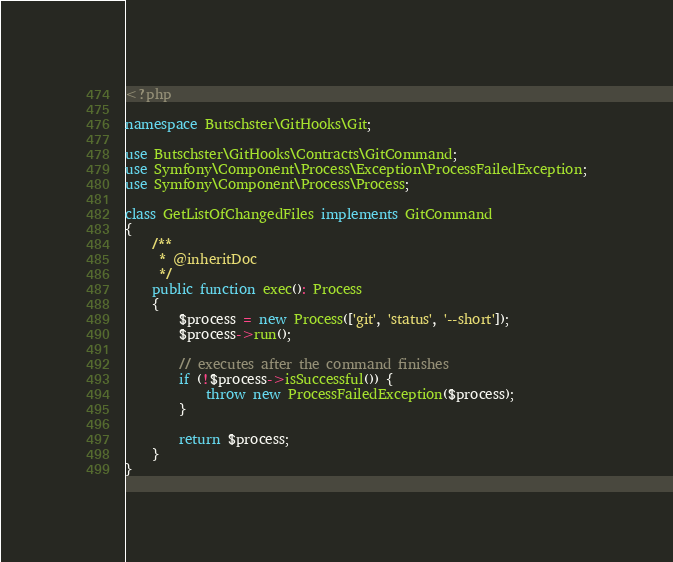<code> <loc_0><loc_0><loc_500><loc_500><_PHP_><?php

namespace Butschster\GitHooks\Git;

use Butschster\GitHooks\Contracts\GitCommand;
use Symfony\Component\Process\Exception\ProcessFailedException;
use Symfony\Component\Process\Process;

class GetListOfChangedFiles implements GitCommand
{
    /**
     * @inheritDoc
     */
    public function exec(): Process
    {
        $process = new Process(['git', 'status', '--short']);
        $process->run();

        // executes after the command finishes
        if (!$process->isSuccessful()) {
            throw new ProcessFailedException($process);
        }

        return $process;
    }
}
</code> 